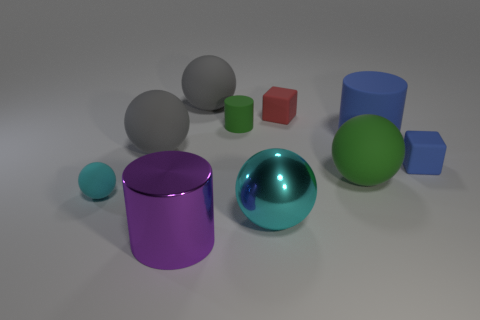What color is the sphere in front of the small cyan sphere left of the big purple cylinder in front of the red object?
Offer a very short reply. Cyan. Does the cube left of the big green object have the same material as the large purple cylinder?
Give a very brief answer. No. Is there another metal cylinder of the same color as the small cylinder?
Ensure brevity in your answer.  No. Is there a gray rubber object?
Your response must be concise. Yes. There is a rubber cube that is right of the green ball; does it have the same size as the red object?
Make the answer very short. Yes. Is the number of big gray rubber balls less than the number of large rubber balls?
Offer a very short reply. Yes. There is a metallic thing that is in front of the cyan ball right of the big gray matte thing that is in front of the red matte cube; what shape is it?
Your answer should be very brief. Cylinder. Is there a large cyan sphere that has the same material as the big blue cylinder?
Offer a very short reply. No. Is the color of the sphere in front of the cyan rubber sphere the same as the tiny matte object in front of the green ball?
Your answer should be very brief. Yes. Is the number of green rubber cylinders that are in front of the big cyan thing less than the number of small green things?
Offer a terse response. Yes. 